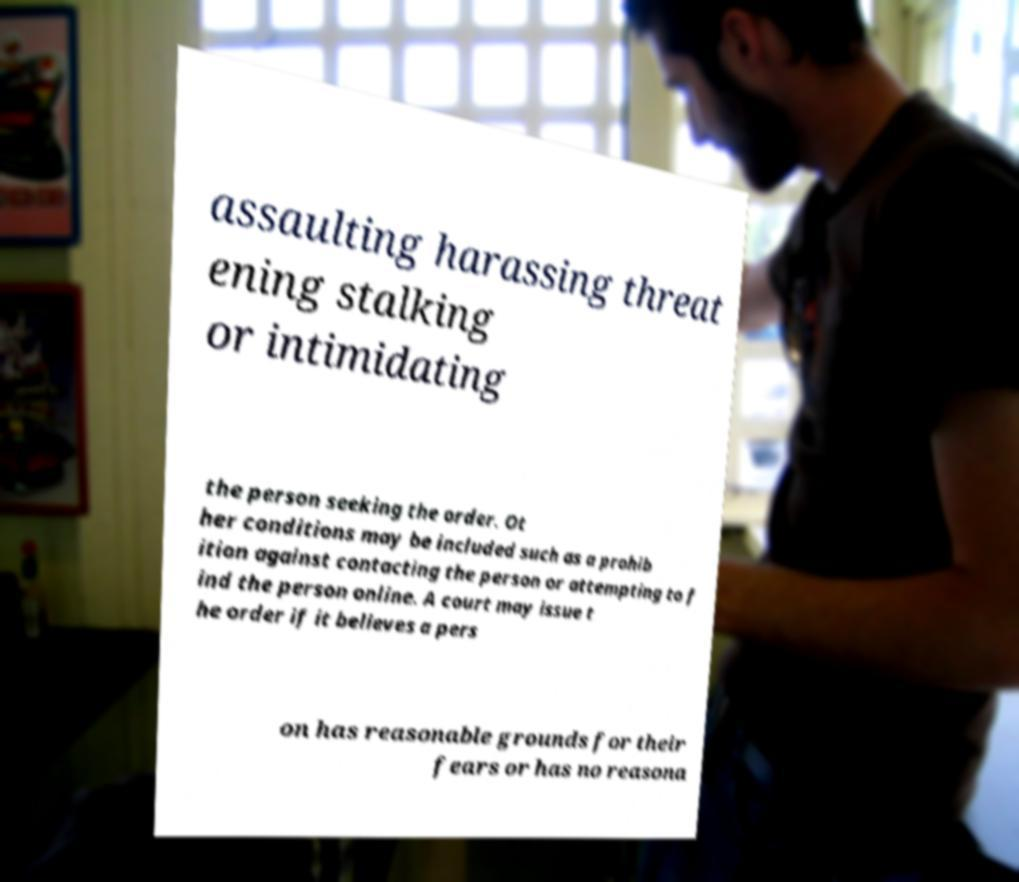Could you assist in decoding the text presented in this image and type it out clearly? assaulting harassing threat ening stalking or intimidating the person seeking the order. Ot her conditions may be included such as a prohib ition against contacting the person or attempting to f ind the person online. A court may issue t he order if it believes a pers on has reasonable grounds for their fears or has no reasona 